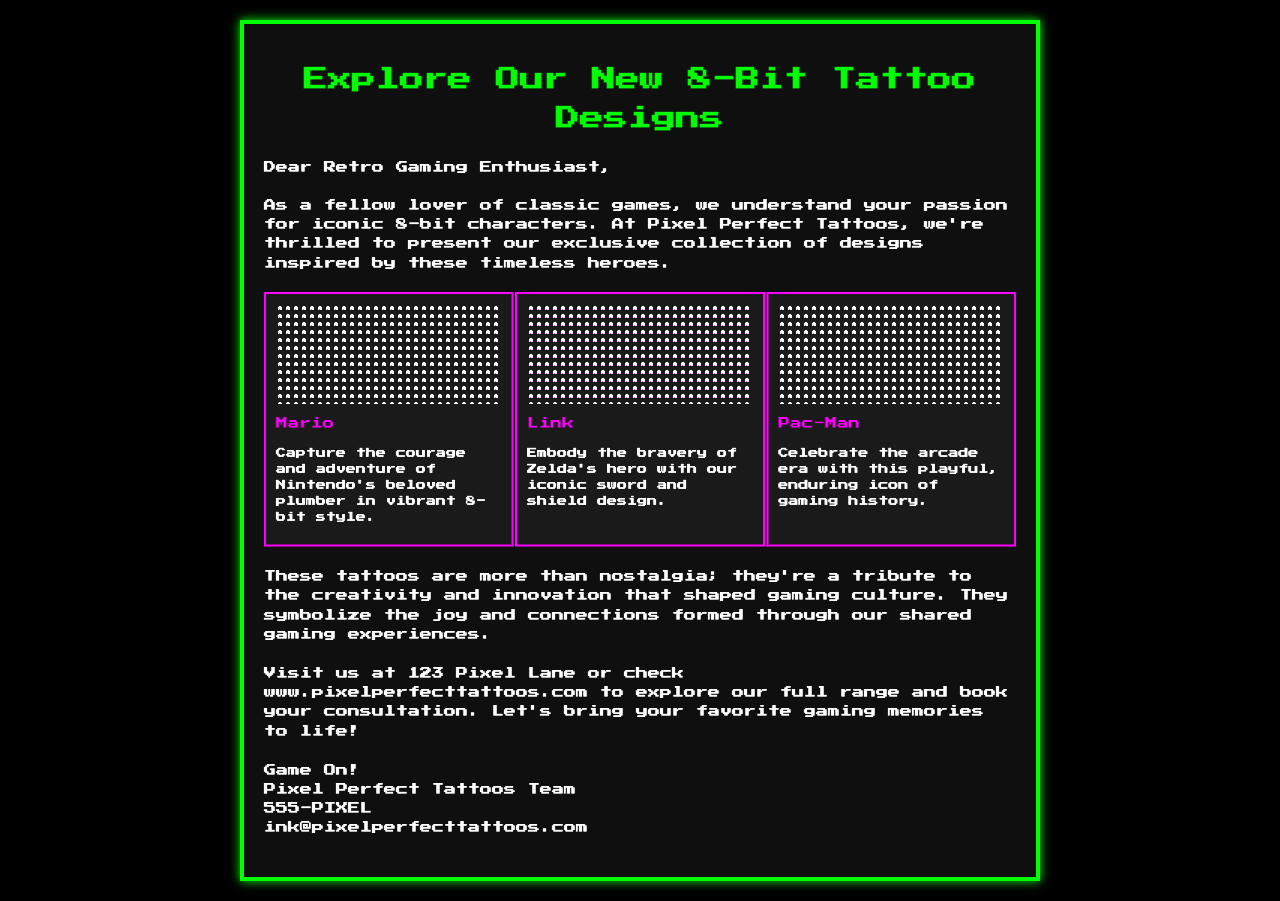what is the name of the tattoo studio? The name of the tattoo studio is mentioned in the intro of the document.
Answer: Pixel Perfect Tattoos how many designs are showcased in the document? The designs listed in the document are Mario, Link, and Pac-Man, totaling three designs.
Answer: 3 what is the design associated with the character Mario? The description of Mario indicates that the design captures courage and adventure.
Answer: Courage and adventure what is the address of the tattoo studio? The address is provided in the call to action section of the document.
Answer: 123 Pixel Lane what symbolism do the tattoos represent? The significance section states the tattoos symbolize joy and connections.
Answer: Joy and connections who is the hero depicted in the Link design? The hero associated with Link's design is stated in the description.
Answer: Zelda what website can be visited for more information? The website is mentioned in the call to action for exploring the full range and booking consultations.
Answer: www.pixelperfecttattoos.com what is the contact number for the tattoo studio? The contact number is provided at the end of the document.
Answer: 555-PIXEL what element of gaming culture do these tattoos pay tribute to? The document highlights that the tattoos pay tribute to creativity and innovation in gaming.
Answer: Creativity and innovation 